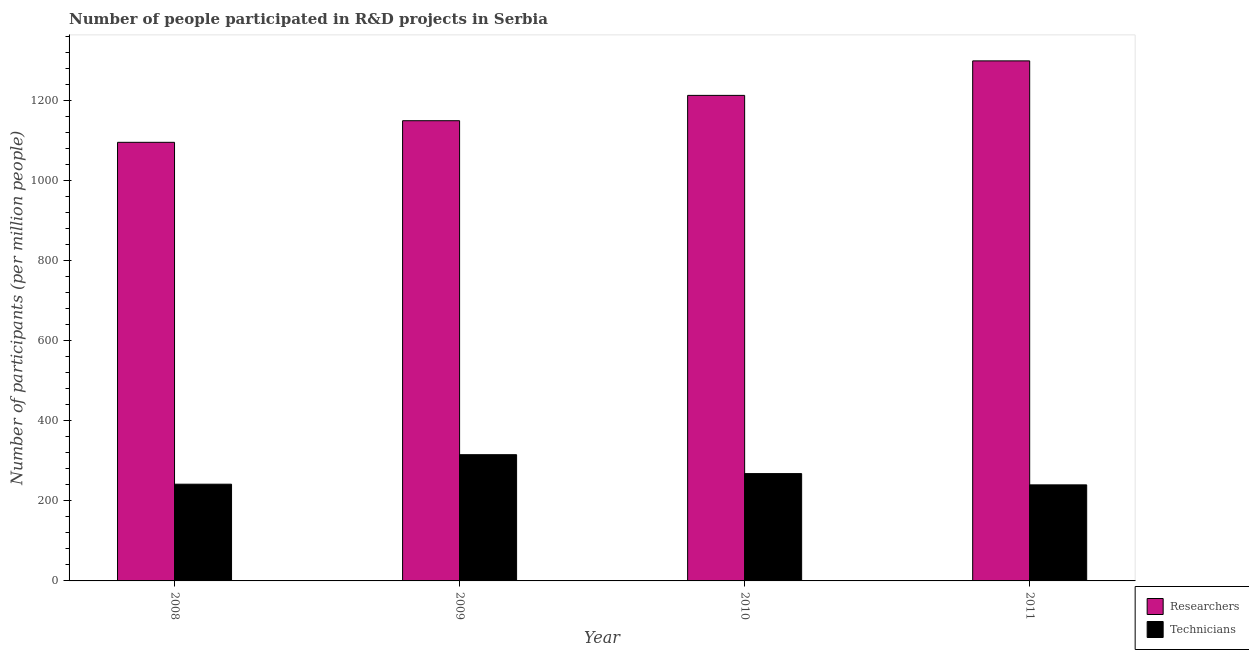What is the label of the 3rd group of bars from the left?
Give a very brief answer. 2010. In how many cases, is the number of bars for a given year not equal to the number of legend labels?
Your answer should be very brief. 0. What is the number of researchers in 2010?
Your answer should be very brief. 1212.59. Across all years, what is the maximum number of researchers?
Provide a short and direct response. 1298.76. Across all years, what is the minimum number of technicians?
Your answer should be compact. 239.9. In which year was the number of researchers minimum?
Your answer should be compact. 2008. What is the total number of technicians in the graph?
Offer a terse response. 1064.76. What is the difference between the number of technicians in 2008 and that in 2011?
Make the answer very short. 1.69. What is the difference between the number of technicians in 2011 and the number of researchers in 2010?
Your answer should be compact. -28.13. What is the average number of technicians per year?
Provide a succinct answer. 266.19. In the year 2011, what is the difference between the number of researchers and number of technicians?
Your answer should be compact. 0. What is the ratio of the number of technicians in 2008 to that in 2011?
Ensure brevity in your answer.  1.01. Is the number of researchers in 2009 less than that in 2011?
Make the answer very short. Yes. What is the difference between the highest and the second highest number of researchers?
Your answer should be compact. 86.17. What is the difference between the highest and the lowest number of technicians?
Offer a terse response. 75.36. What does the 1st bar from the left in 2010 represents?
Your response must be concise. Researchers. What does the 2nd bar from the right in 2011 represents?
Make the answer very short. Researchers. How many bars are there?
Provide a short and direct response. 8. What is the difference between two consecutive major ticks on the Y-axis?
Ensure brevity in your answer.  200. Are the values on the major ticks of Y-axis written in scientific E-notation?
Your answer should be very brief. No. Does the graph contain any zero values?
Keep it short and to the point. No. How are the legend labels stacked?
Ensure brevity in your answer.  Vertical. What is the title of the graph?
Make the answer very short. Number of people participated in R&D projects in Serbia. What is the label or title of the X-axis?
Provide a short and direct response. Year. What is the label or title of the Y-axis?
Provide a succinct answer. Number of participants (per million people). What is the Number of participants (per million people) in Researchers in 2008?
Ensure brevity in your answer.  1095.36. What is the Number of participants (per million people) of Technicians in 2008?
Give a very brief answer. 241.58. What is the Number of participants (per million people) of Researchers in 2009?
Provide a short and direct response. 1149.33. What is the Number of participants (per million people) of Technicians in 2009?
Offer a very short reply. 315.25. What is the Number of participants (per million people) of Researchers in 2010?
Offer a very short reply. 1212.59. What is the Number of participants (per million people) of Technicians in 2010?
Keep it short and to the point. 268.03. What is the Number of participants (per million people) of Researchers in 2011?
Your response must be concise. 1298.76. What is the Number of participants (per million people) of Technicians in 2011?
Keep it short and to the point. 239.9. Across all years, what is the maximum Number of participants (per million people) in Researchers?
Your answer should be compact. 1298.76. Across all years, what is the maximum Number of participants (per million people) of Technicians?
Keep it short and to the point. 315.25. Across all years, what is the minimum Number of participants (per million people) of Researchers?
Keep it short and to the point. 1095.36. Across all years, what is the minimum Number of participants (per million people) in Technicians?
Your response must be concise. 239.9. What is the total Number of participants (per million people) of Researchers in the graph?
Give a very brief answer. 4756.04. What is the total Number of participants (per million people) of Technicians in the graph?
Ensure brevity in your answer.  1064.76. What is the difference between the Number of participants (per million people) of Researchers in 2008 and that in 2009?
Give a very brief answer. -53.97. What is the difference between the Number of participants (per million people) of Technicians in 2008 and that in 2009?
Provide a short and direct response. -73.67. What is the difference between the Number of participants (per million people) in Researchers in 2008 and that in 2010?
Keep it short and to the point. -117.24. What is the difference between the Number of participants (per million people) in Technicians in 2008 and that in 2010?
Ensure brevity in your answer.  -26.45. What is the difference between the Number of participants (per million people) of Researchers in 2008 and that in 2011?
Your response must be concise. -203.41. What is the difference between the Number of participants (per million people) in Technicians in 2008 and that in 2011?
Make the answer very short. 1.69. What is the difference between the Number of participants (per million people) in Researchers in 2009 and that in 2010?
Give a very brief answer. -63.27. What is the difference between the Number of participants (per million people) of Technicians in 2009 and that in 2010?
Give a very brief answer. 47.22. What is the difference between the Number of participants (per million people) in Researchers in 2009 and that in 2011?
Keep it short and to the point. -149.44. What is the difference between the Number of participants (per million people) in Technicians in 2009 and that in 2011?
Provide a succinct answer. 75.36. What is the difference between the Number of participants (per million people) of Researchers in 2010 and that in 2011?
Give a very brief answer. -86.17. What is the difference between the Number of participants (per million people) in Technicians in 2010 and that in 2011?
Your response must be concise. 28.13. What is the difference between the Number of participants (per million people) of Researchers in 2008 and the Number of participants (per million people) of Technicians in 2009?
Provide a succinct answer. 780.11. What is the difference between the Number of participants (per million people) in Researchers in 2008 and the Number of participants (per million people) in Technicians in 2010?
Your answer should be very brief. 827.33. What is the difference between the Number of participants (per million people) of Researchers in 2008 and the Number of participants (per million people) of Technicians in 2011?
Provide a succinct answer. 855.46. What is the difference between the Number of participants (per million people) of Researchers in 2009 and the Number of participants (per million people) of Technicians in 2010?
Your response must be concise. 881.29. What is the difference between the Number of participants (per million people) in Researchers in 2009 and the Number of participants (per million people) in Technicians in 2011?
Give a very brief answer. 909.43. What is the difference between the Number of participants (per million people) in Researchers in 2010 and the Number of participants (per million people) in Technicians in 2011?
Offer a terse response. 972.7. What is the average Number of participants (per million people) in Researchers per year?
Keep it short and to the point. 1189.01. What is the average Number of participants (per million people) in Technicians per year?
Make the answer very short. 266.19. In the year 2008, what is the difference between the Number of participants (per million people) in Researchers and Number of participants (per million people) in Technicians?
Ensure brevity in your answer.  853.78. In the year 2009, what is the difference between the Number of participants (per million people) in Researchers and Number of participants (per million people) in Technicians?
Provide a short and direct response. 834.07. In the year 2010, what is the difference between the Number of participants (per million people) in Researchers and Number of participants (per million people) in Technicians?
Give a very brief answer. 944.56. In the year 2011, what is the difference between the Number of participants (per million people) of Researchers and Number of participants (per million people) of Technicians?
Keep it short and to the point. 1058.87. What is the ratio of the Number of participants (per million people) in Researchers in 2008 to that in 2009?
Provide a succinct answer. 0.95. What is the ratio of the Number of participants (per million people) in Technicians in 2008 to that in 2009?
Keep it short and to the point. 0.77. What is the ratio of the Number of participants (per million people) in Researchers in 2008 to that in 2010?
Give a very brief answer. 0.9. What is the ratio of the Number of participants (per million people) of Technicians in 2008 to that in 2010?
Make the answer very short. 0.9. What is the ratio of the Number of participants (per million people) in Researchers in 2008 to that in 2011?
Make the answer very short. 0.84. What is the ratio of the Number of participants (per million people) in Technicians in 2008 to that in 2011?
Your answer should be very brief. 1.01. What is the ratio of the Number of participants (per million people) in Researchers in 2009 to that in 2010?
Provide a succinct answer. 0.95. What is the ratio of the Number of participants (per million people) in Technicians in 2009 to that in 2010?
Offer a very short reply. 1.18. What is the ratio of the Number of participants (per million people) in Researchers in 2009 to that in 2011?
Your response must be concise. 0.88. What is the ratio of the Number of participants (per million people) in Technicians in 2009 to that in 2011?
Ensure brevity in your answer.  1.31. What is the ratio of the Number of participants (per million people) in Researchers in 2010 to that in 2011?
Your response must be concise. 0.93. What is the ratio of the Number of participants (per million people) in Technicians in 2010 to that in 2011?
Your answer should be very brief. 1.12. What is the difference between the highest and the second highest Number of participants (per million people) in Researchers?
Keep it short and to the point. 86.17. What is the difference between the highest and the second highest Number of participants (per million people) in Technicians?
Provide a short and direct response. 47.22. What is the difference between the highest and the lowest Number of participants (per million people) of Researchers?
Give a very brief answer. 203.41. What is the difference between the highest and the lowest Number of participants (per million people) of Technicians?
Your answer should be compact. 75.36. 